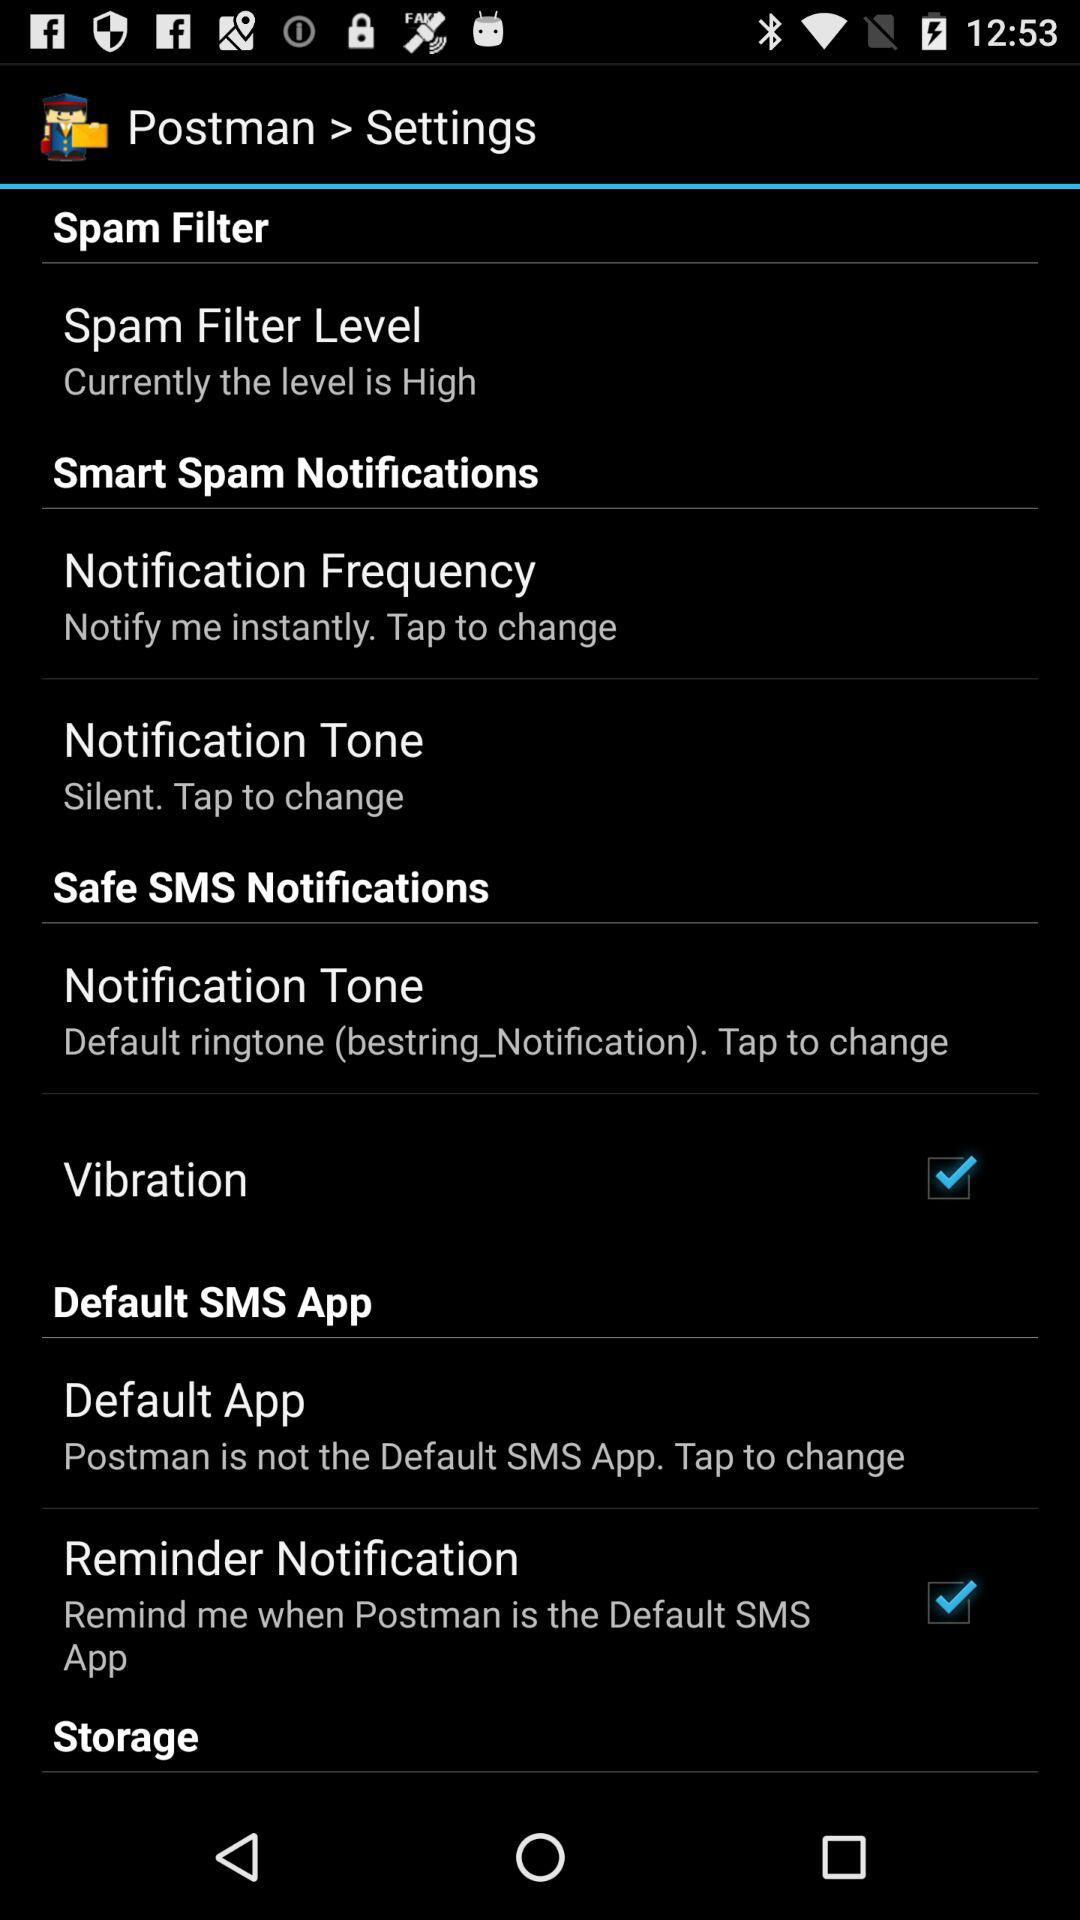What is the status of the "Vibration"? The status of the "Vibration" is "on". 